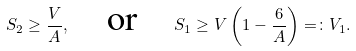<formula> <loc_0><loc_0><loc_500><loc_500>S _ { 2 } \geq \frac { V } { A } , \quad \text {or} \quad S _ { 1 } \geq V \left ( 1 - \frac { 6 } { A } \right ) = \colon V _ { 1 } .</formula> 